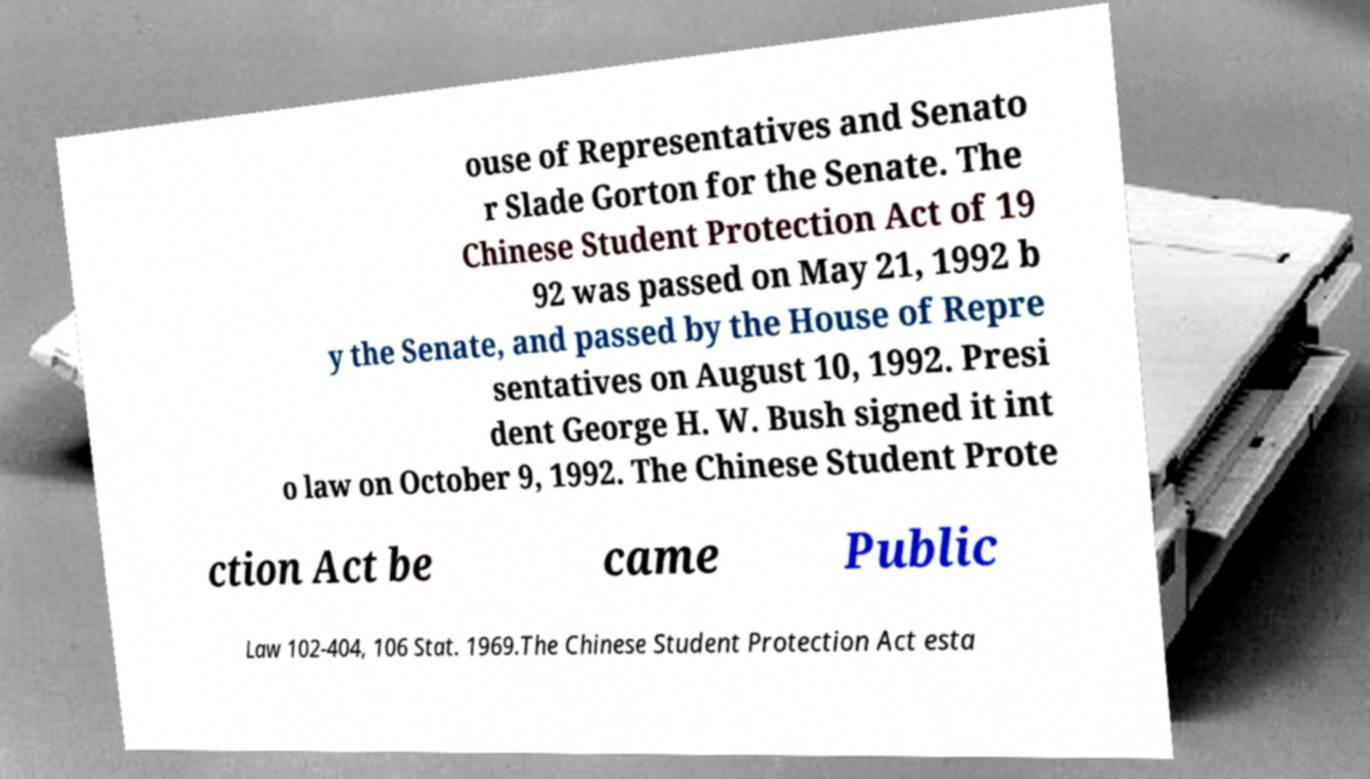Could you assist in decoding the text presented in this image and type it out clearly? ouse of Representatives and Senato r Slade Gorton for the Senate. The Chinese Student Protection Act of 19 92 was passed on May 21, 1992 b y the Senate, and passed by the House of Repre sentatives on August 10, 1992. Presi dent George H. W. Bush signed it int o law on October 9, 1992. The Chinese Student Prote ction Act be came Public Law 102-404, 106 Stat. 1969.The Chinese Student Protection Act esta 